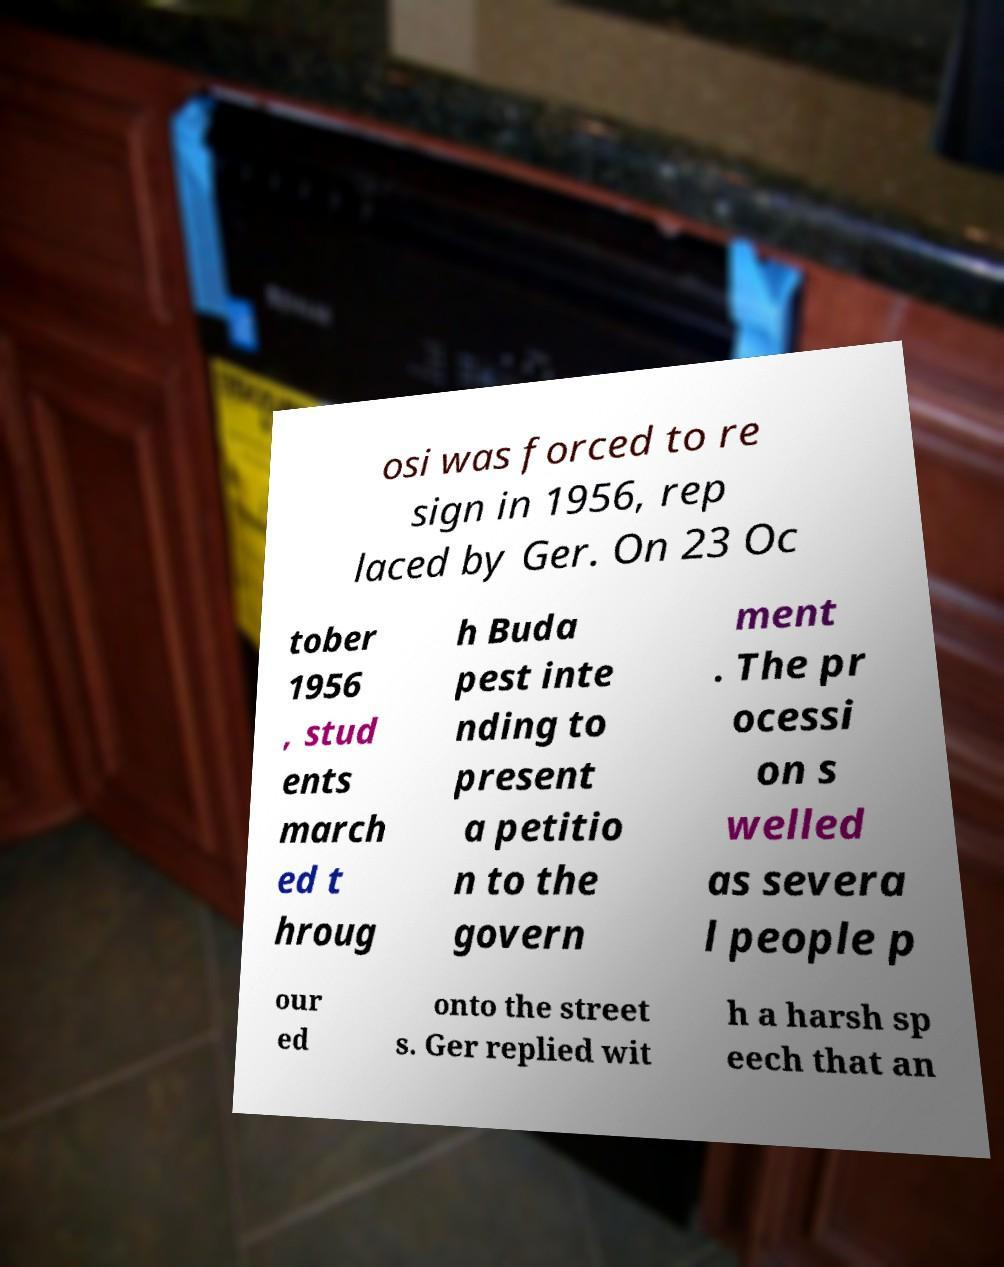Please read and relay the text visible in this image. What does it say? osi was forced to re sign in 1956, rep laced by Ger. On 23 Oc tober 1956 , stud ents march ed t hroug h Buda pest inte nding to present a petitio n to the govern ment . The pr ocessi on s welled as severa l people p our ed onto the street s. Ger replied wit h a harsh sp eech that an 